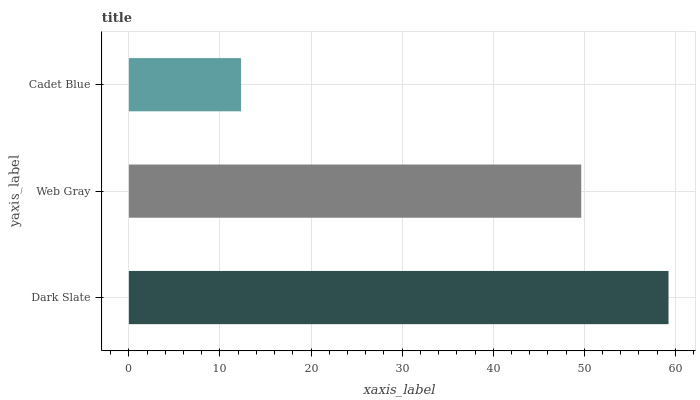Is Cadet Blue the minimum?
Answer yes or no. Yes. Is Dark Slate the maximum?
Answer yes or no. Yes. Is Web Gray the minimum?
Answer yes or no. No. Is Web Gray the maximum?
Answer yes or no. No. Is Dark Slate greater than Web Gray?
Answer yes or no. Yes. Is Web Gray less than Dark Slate?
Answer yes or no. Yes. Is Web Gray greater than Dark Slate?
Answer yes or no. No. Is Dark Slate less than Web Gray?
Answer yes or no. No. Is Web Gray the high median?
Answer yes or no. Yes. Is Web Gray the low median?
Answer yes or no. Yes. Is Cadet Blue the high median?
Answer yes or no. No. Is Cadet Blue the low median?
Answer yes or no. No. 